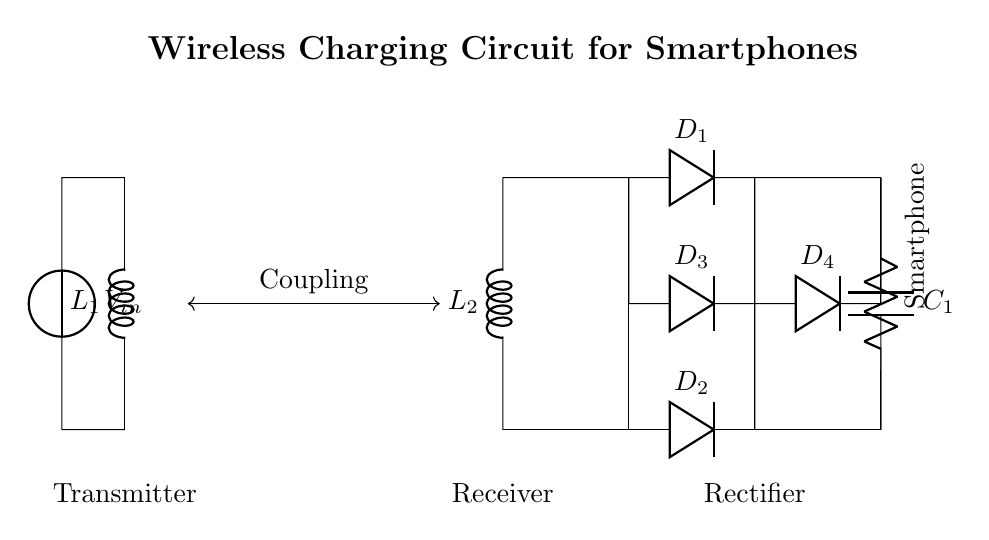What are the primary components of this circuit? The primary components are the primary coil, secondary coil, rectifier, capacitor, and smartphone load. These are clearly labeled in the diagram.
Answer: primary coil, secondary coil, rectifier, capacitor, smartphone What is the function of the diodes in the circuit? The diodes are used for rectification, allowing current to flow in only one direction, thereby converting alternating current from the coils into direct current for the load. This is essential for charging the smartphone.
Answer: rectification Which component is labeled as the load? The load in this circuit is labeled as the smartphone, which represents the device being charged. It is indicated in the bottom part of the circuit connected to the capacitor and rectifier.
Answer: smartphone What is the role of the smoothing capacitor? The smoothing capacitor smooths the output voltage from the rectifier by reducing voltage ripple, providing a more constant voltage to the load (smartphone). This ensures stable charging.
Answer: smoothing How do the primary and secondary coils interact? The primary and secondary coils interact through electromagnetic induction, converting the electrical energy in the primary coil into a magnetic field, which induces voltage in the secondary coil, enabling wireless power transfer.
Answer: electromagnetic induction Which part of the circuit is the rectifier located? The rectifier is located between the secondary coil and the smoothing capacitor, converting the alternating current induced in the secondary coil to direct current for charging the smartphone.
Answer: between the secondary coil and the smoothing capacitor What type of circuit is this? This is a wireless charging circuit specifically designed for smartphones, utilizing electromagnetic induction to transfer energy without physical connections.
Answer: wireless charging circuit 